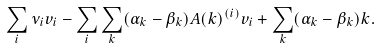Convert formula to latex. <formula><loc_0><loc_0><loc_500><loc_500>\sum _ { i } \nu _ { i } v _ { i } - \sum _ { i } \sum _ { k } ( \alpha _ { k } - \beta _ { k } ) A ( k ) ^ { ( i ) } v _ { i } + \sum _ { k } ( \alpha _ { k } - \beta _ { k } ) k .</formula> 